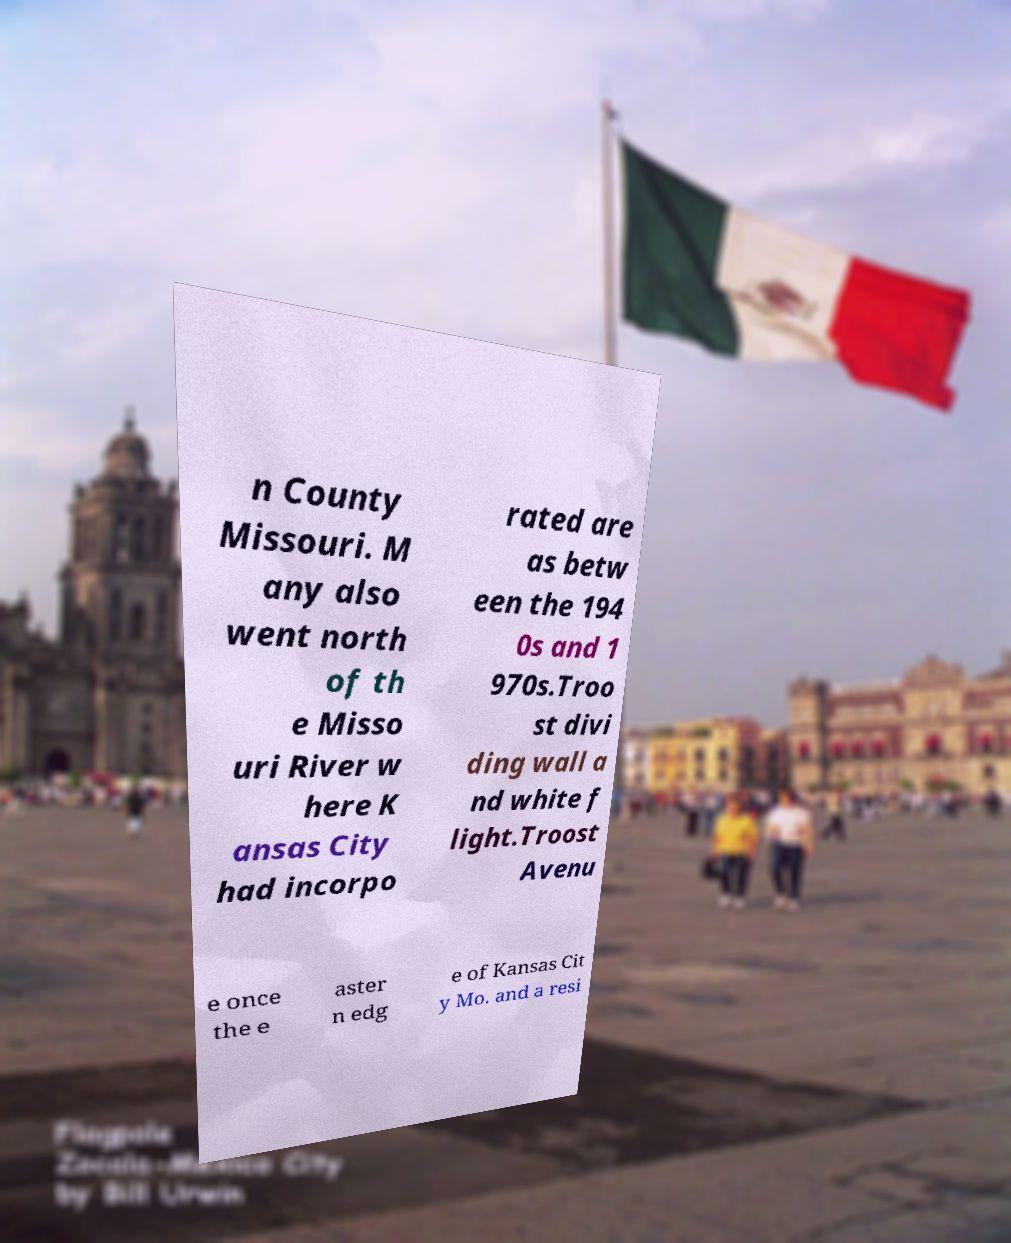Can you read and provide the text displayed in the image?This photo seems to have some interesting text. Can you extract and type it out for me? n County Missouri. M any also went north of th e Misso uri River w here K ansas City had incorpo rated are as betw een the 194 0s and 1 970s.Troo st divi ding wall a nd white f light.Troost Avenu e once the e aster n edg e of Kansas Cit y Mo. and a resi 